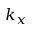<formula> <loc_0><loc_0><loc_500><loc_500>k _ { x }</formula> 